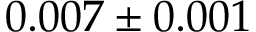<formula> <loc_0><loc_0><loc_500><loc_500>0 . 0 0 7 \pm 0 . 0 0 1</formula> 